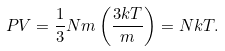<formula> <loc_0><loc_0><loc_500><loc_500>P V = { \frac { 1 } { 3 } } N m \left ( { \frac { 3 k T } { m } } \right ) = N k T .</formula> 